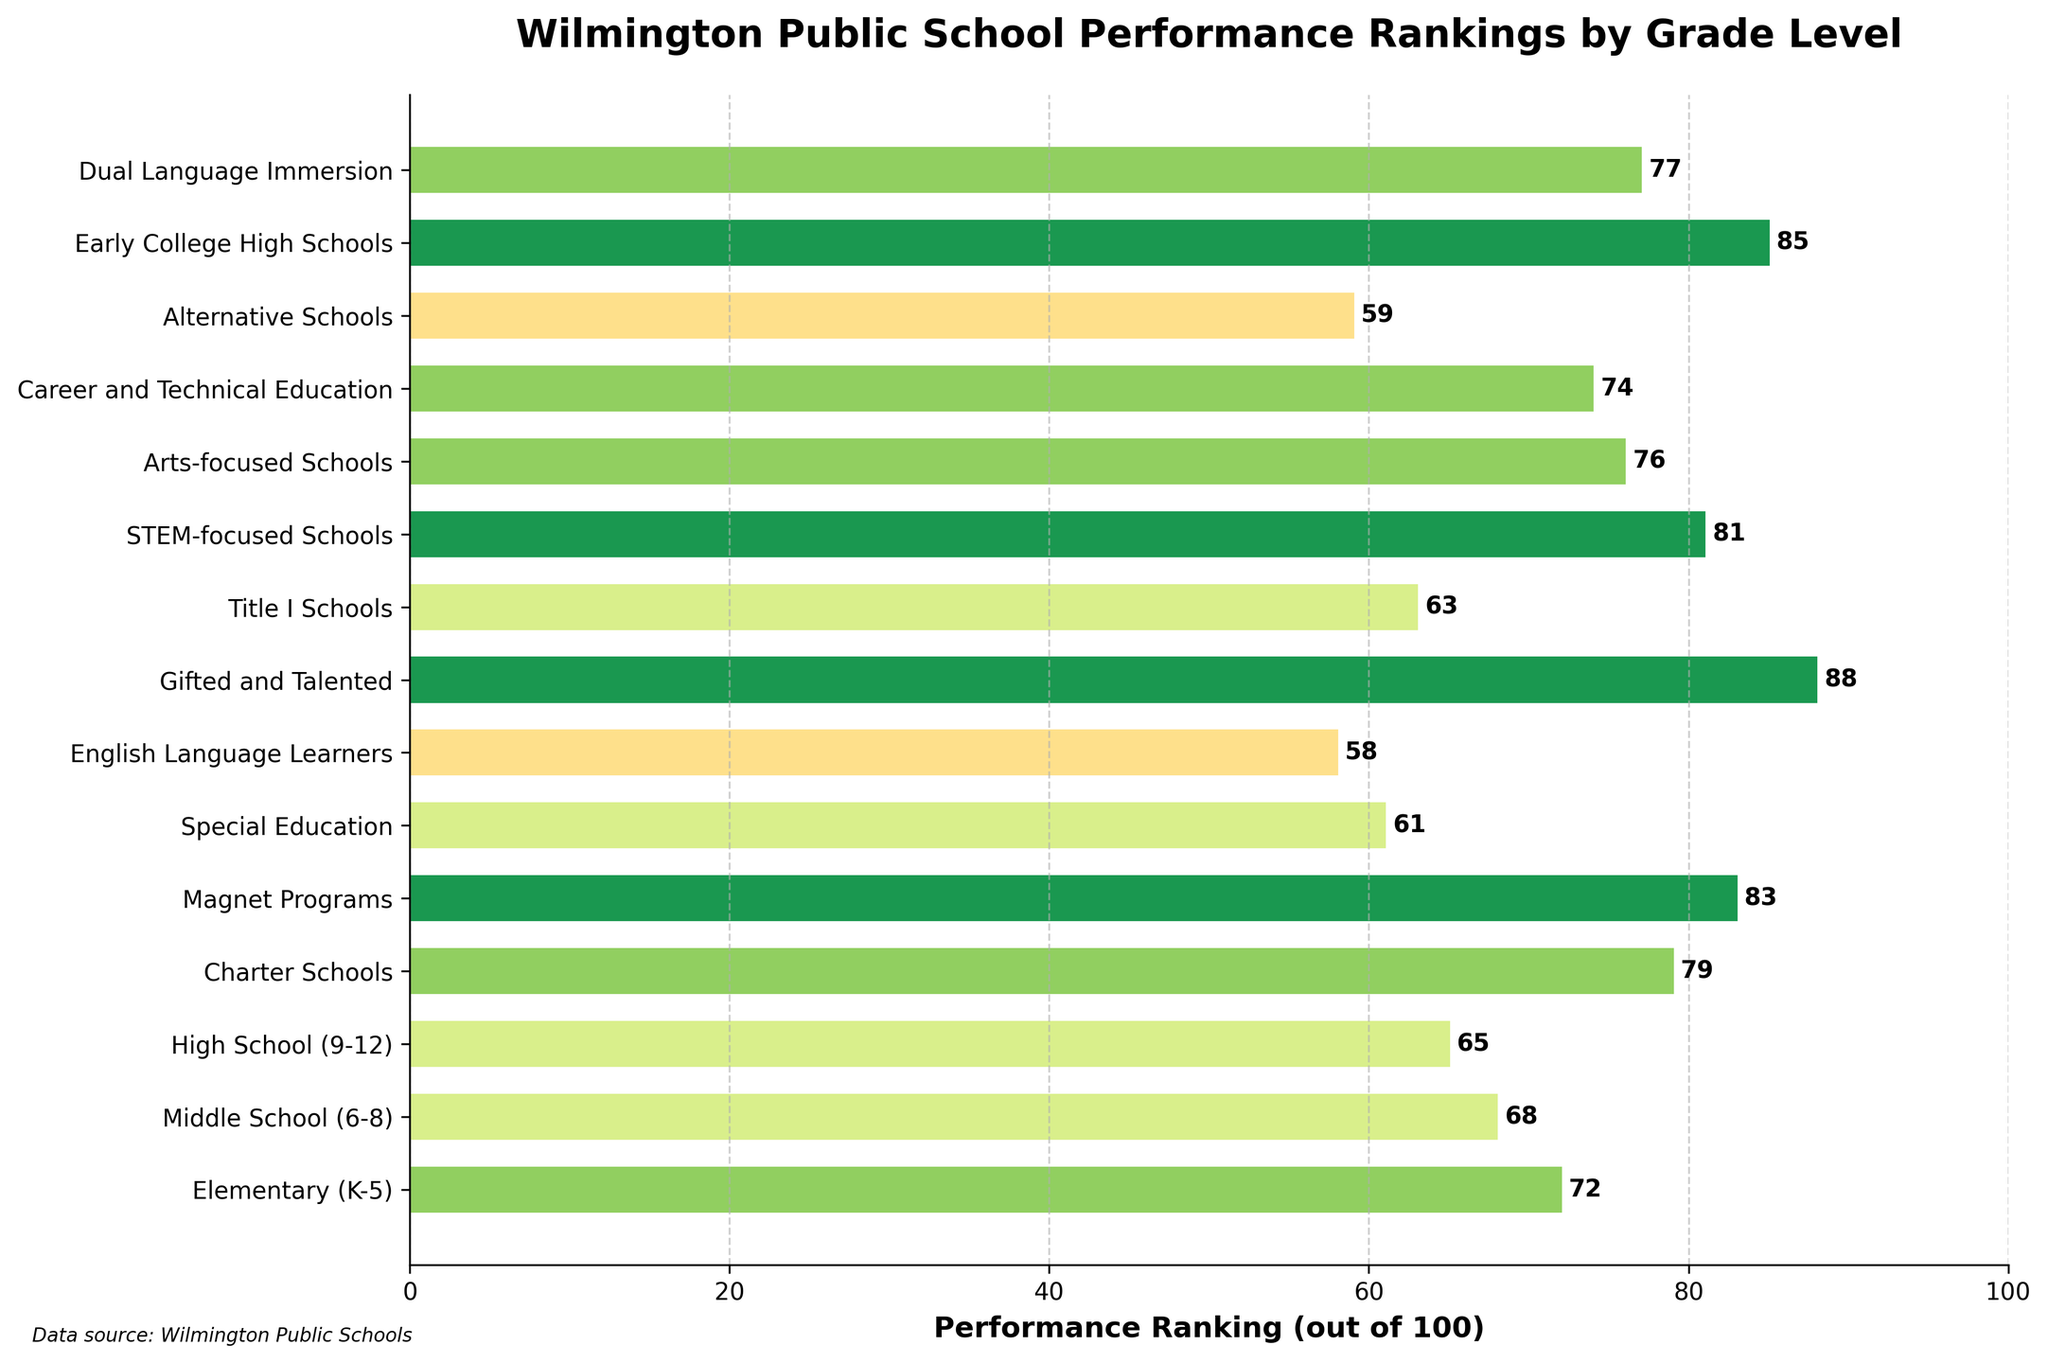Which grade level has the highest performance ranking? The bar chart shows that the Gifted and Talented programs have the highest performance ranking, with a value of 88.
Answer: Gifted and Talented How do the performance rankings of the Middle School (6-8) and High School (9-12) compare? In the chart, the performance ranking for Middle School (6-8) is 68, while for High School (9-12), it is 65. This shows that Middle Schools have a slightly higher performance ranking than High Schools.
Answer: Middle Schools have a higher performance ranking than High Schools What is the average performance ranking of Elementary (K-5), Middle School (6-8), and High School (9-12)? To find the average, add the rankings for Elementary (72), Middle School (68), and High School (65), and then divide by 3. The calculation is (72 + 68 + 65) / 3 = 205 / 3 ≈ 68.3.
Answer: 68.3 Which school type ranks higher, Charter Schools or STEM-focused Schools? According to the chart, Charter Schools have a performance ranking of 79, while STEM-focused Schools have a ranking of 81. STEM-focused Schools rank higher than Charter Schools.
Answer: STEM-focused Schools How much lower is the performance ranking of Alternative Schools compared to Arts-focused Schools? The chart shows that Alternative Schools have a ranking of 59, while Arts-focused Schools have a ranking of 76. The difference is 76 - 59 = 17. Alternative Schools are 17 points lower in performance ranking compared to Arts-focused Schools.
Answer: 17 points Are there any school types with performance rankings below 60? If so, which ones? From the chart, there are two school types below the performance ranking of 60: English Language Learners (58) and Alternative Schools (59).
Answer: English Language Learners and Alternative Schools What is the median performance ranking for all the school types listed? To find the median, first arrange the performance rankings in ascending order: 58, 59, 61, 63, 65, 68, 72, 74, 76, 77, 79, 81, 83, 85, 88. With 15 values, the median is the 8th value, which is 74.
Answer: 74 Which school type has the second highest performance ranking, and what is the value? The school type with the highest ranking is Gifted and Talented (88). The second highest is Early College High Schools with a ranking of 85.
Answer: Early College High Schools, 85 How do the performance rankings of Special Education and Title I Schools compare? The chart shows that Special Education has a ranking of 61, while Title I Schools have a ranking of 63. Title I Schools rank slightly higher than Special Education.
Answer: Title I Schools rank higher 